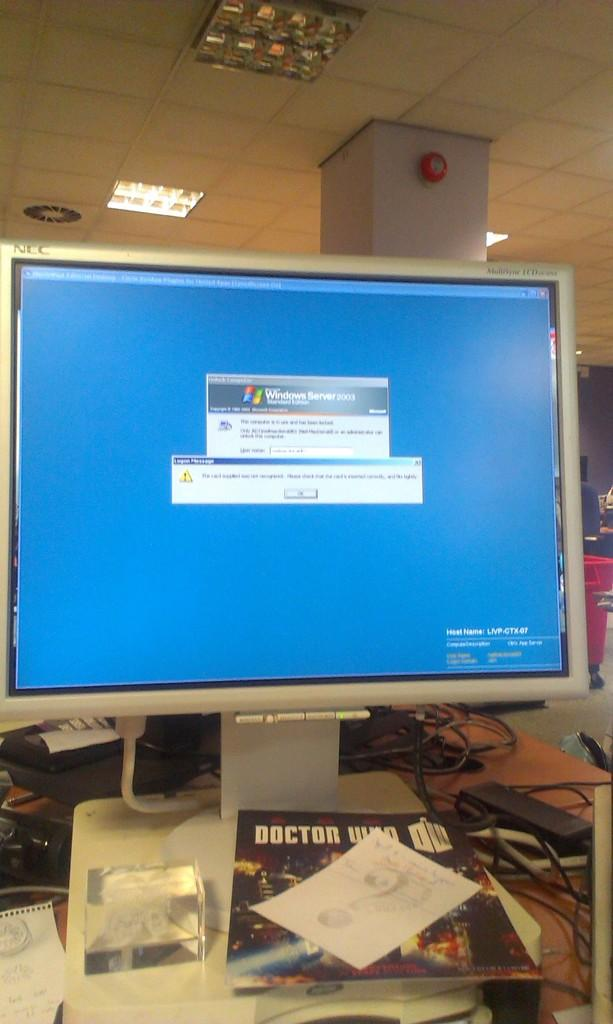<image>
Relay a brief, clear account of the picture shown. the word windows is at the top of the screen 